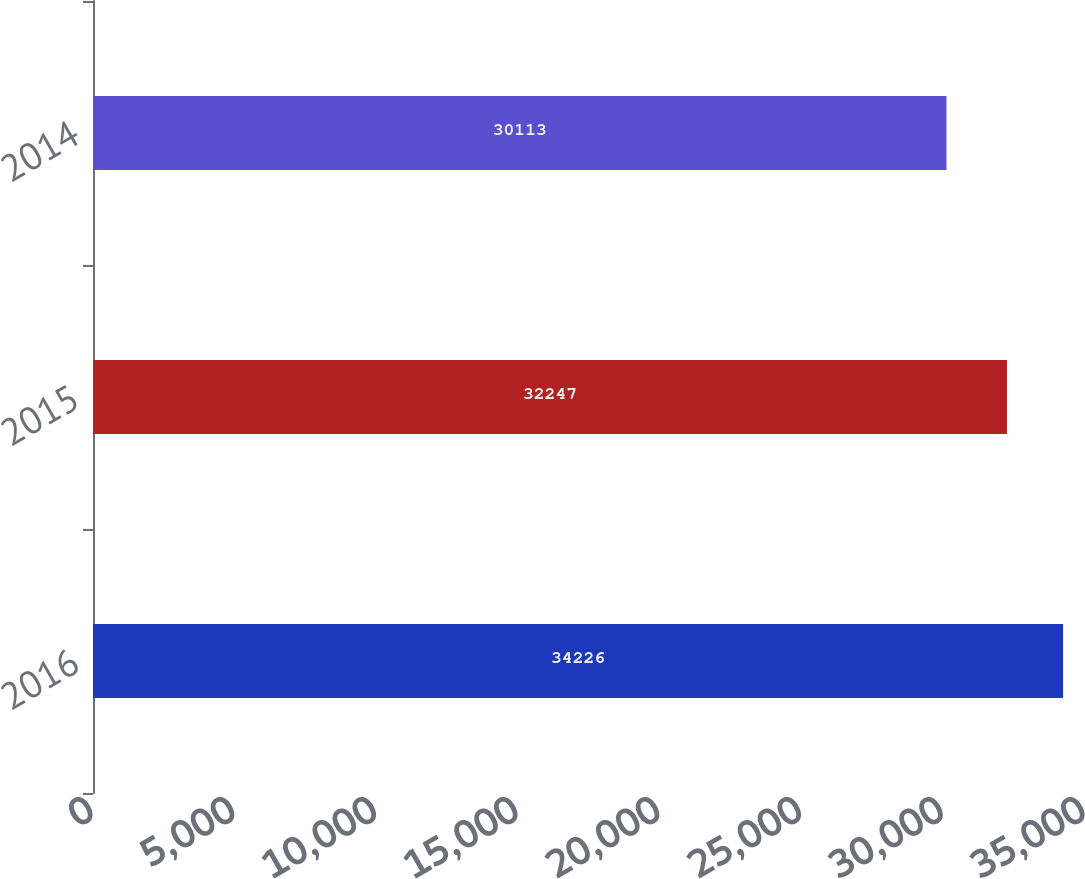Convert chart. <chart><loc_0><loc_0><loc_500><loc_500><bar_chart><fcel>2016<fcel>2015<fcel>2014<nl><fcel>34226<fcel>32247<fcel>30113<nl></chart> 